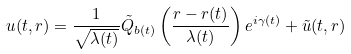Convert formula to latex. <formula><loc_0><loc_0><loc_500><loc_500>u ( t , r ) = \frac { 1 } { \sqrt { \lambda ( t ) } } \tilde { Q } _ { b ( t ) } \left ( \frac { r - r ( t ) } { \lambda ( t ) } \right ) e ^ { i \gamma ( t ) } + \tilde { u } ( t , r )</formula> 